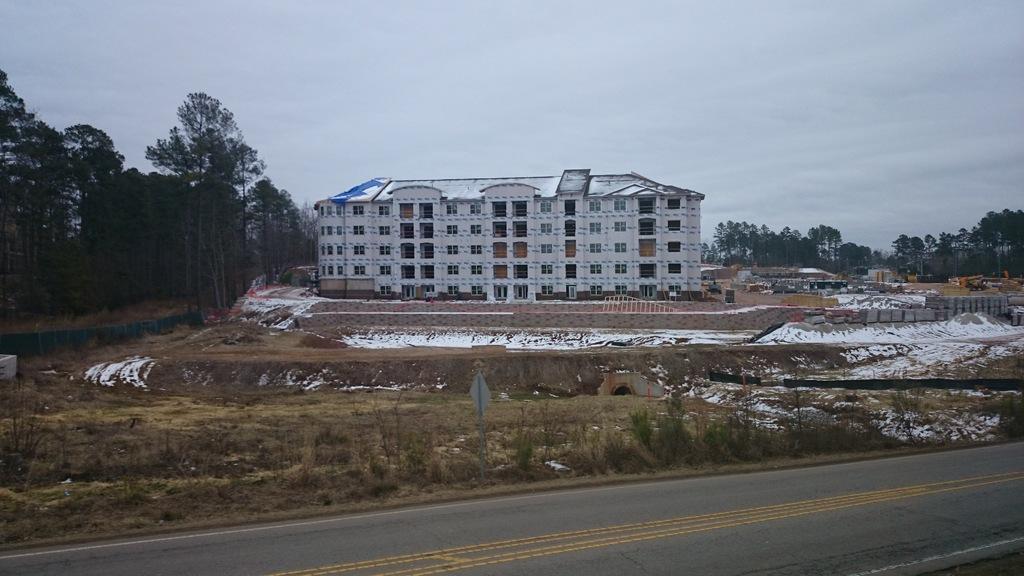Please provide a concise description of this image. In this image we can see a building and it is having many windows. There is a cloudy sky in the image. There are many objects at the right side of the image. There is a road in the image. There is a board in the image. There are many trees and plants in the image. 